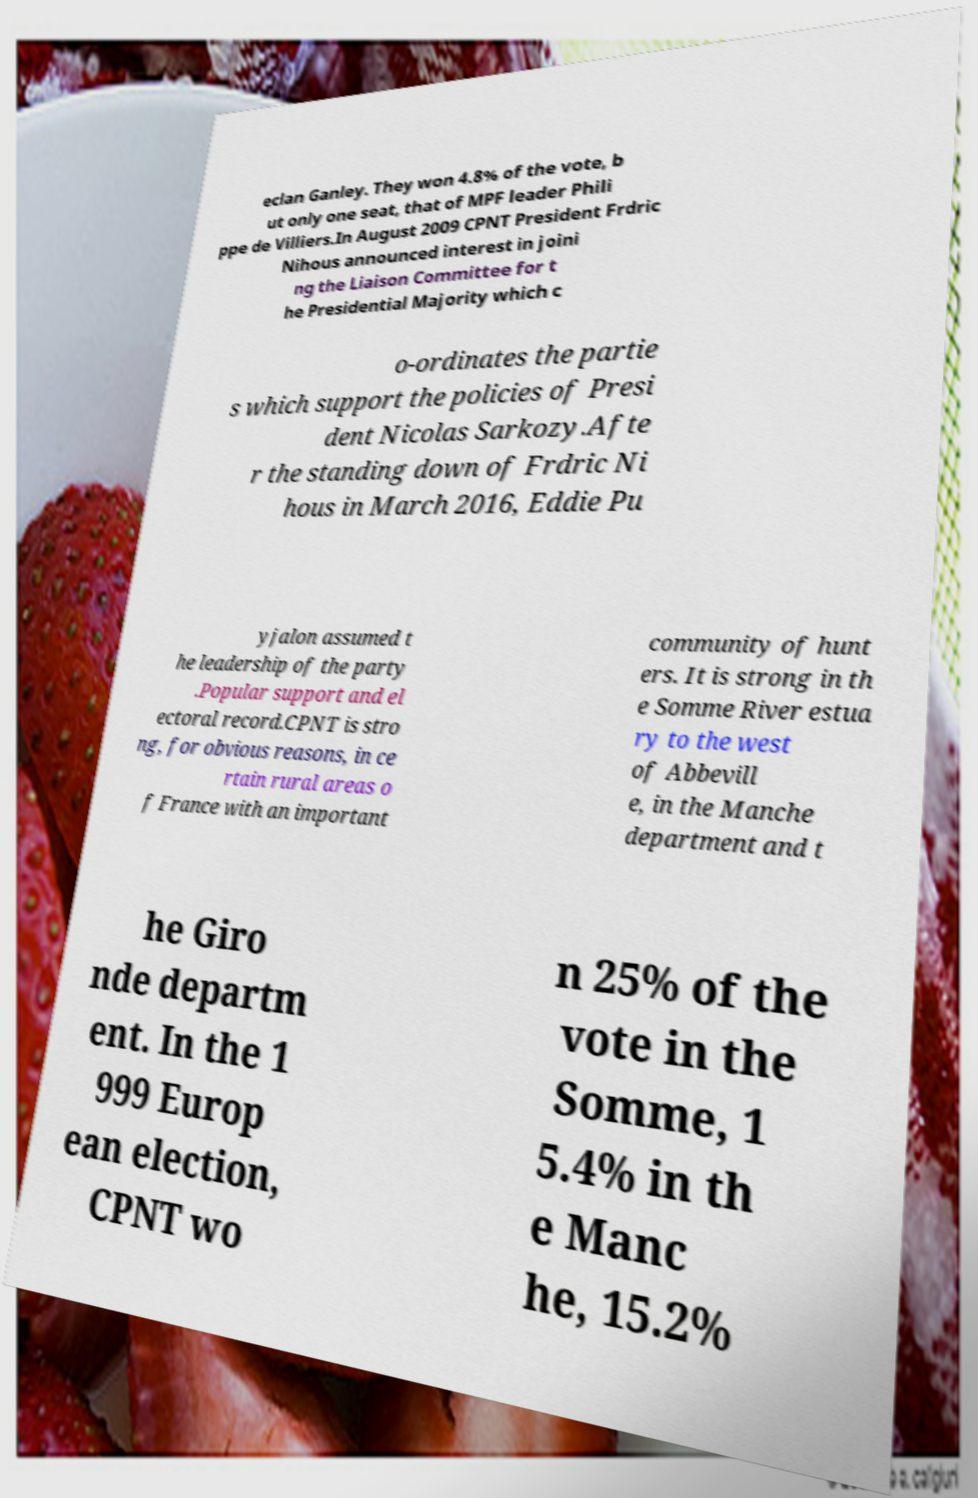Please read and relay the text visible in this image. What does it say? eclan Ganley. They won 4.8% of the vote, b ut only one seat, that of MPF leader Phili ppe de Villiers.In August 2009 CPNT President Frdric Nihous announced interest in joini ng the Liaison Committee for t he Presidential Majority which c o-ordinates the partie s which support the policies of Presi dent Nicolas Sarkozy.Afte r the standing down of Frdric Ni hous in March 2016, Eddie Pu yjalon assumed t he leadership of the party .Popular support and el ectoral record.CPNT is stro ng, for obvious reasons, in ce rtain rural areas o f France with an important community of hunt ers. It is strong in th e Somme River estua ry to the west of Abbevill e, in the Manche department and t he Giro nde departm ent. In the 1 999 Europ ean election, CPNT wo n 25% of the vote in the Somme, 1 5.4% in th e Manc he, 15.2% 